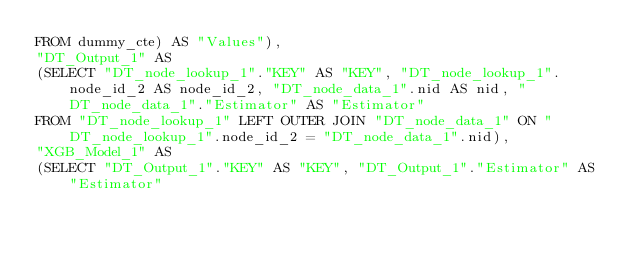<code> <loc_0><loc_0><loc_500><loc_500><_SQL_>FROM dummy_cte) AS "Values"), 
"DT_Output_1" AS 
(SELECT "DT_node_lookup_1"."KEY" AS "KEY", "DT_node_lookup_1".node_id_2 AS node_id_2, "DT_node_data_1".nid AS nid, "DT_node_data_1"."Estimator" AS "Estimator" 
FROM "DT_node_lookup_1" LEFT OUTER JOIN "DT_node_data_1" ON "DT_node_lookup_1".node_id_2 = "DT_node_data_1".nid), 
"XGB_Model_1" AS 
(SELECT "DT_Output_1"."KEY" AS "KEY", "DT_Output_1"."Estimator" AS "Estimator" </code> 